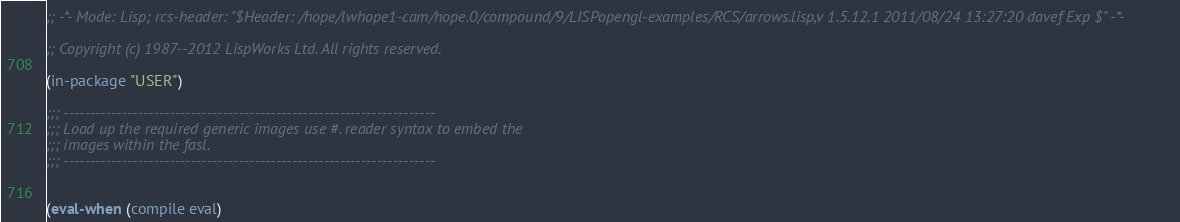<code> <loc_0><loc_0><loc_500><loc_500><_Lisp_>;; -*- Mode: Lisp; rcs-header: "$Header: /hope/lwhope1-cam/hope.0/compound/9/LISPopengl-examples/RCS/arrows.lisp,v 1.5.12.1 2011/08/24 13:27:20 davef Exp $" -*-

;; Copyright (c) 1987--2012 LispWorks Ltd. All rights reserved.

(in-package "USER")

;;; ----------------------------------------------------------------------
;;; Load up the required generic images use #. reader syntax to embed the
;;; images within the fasl.
;;; ----------------------------------------------------------------------


(eval-when (compile eval)</code> 